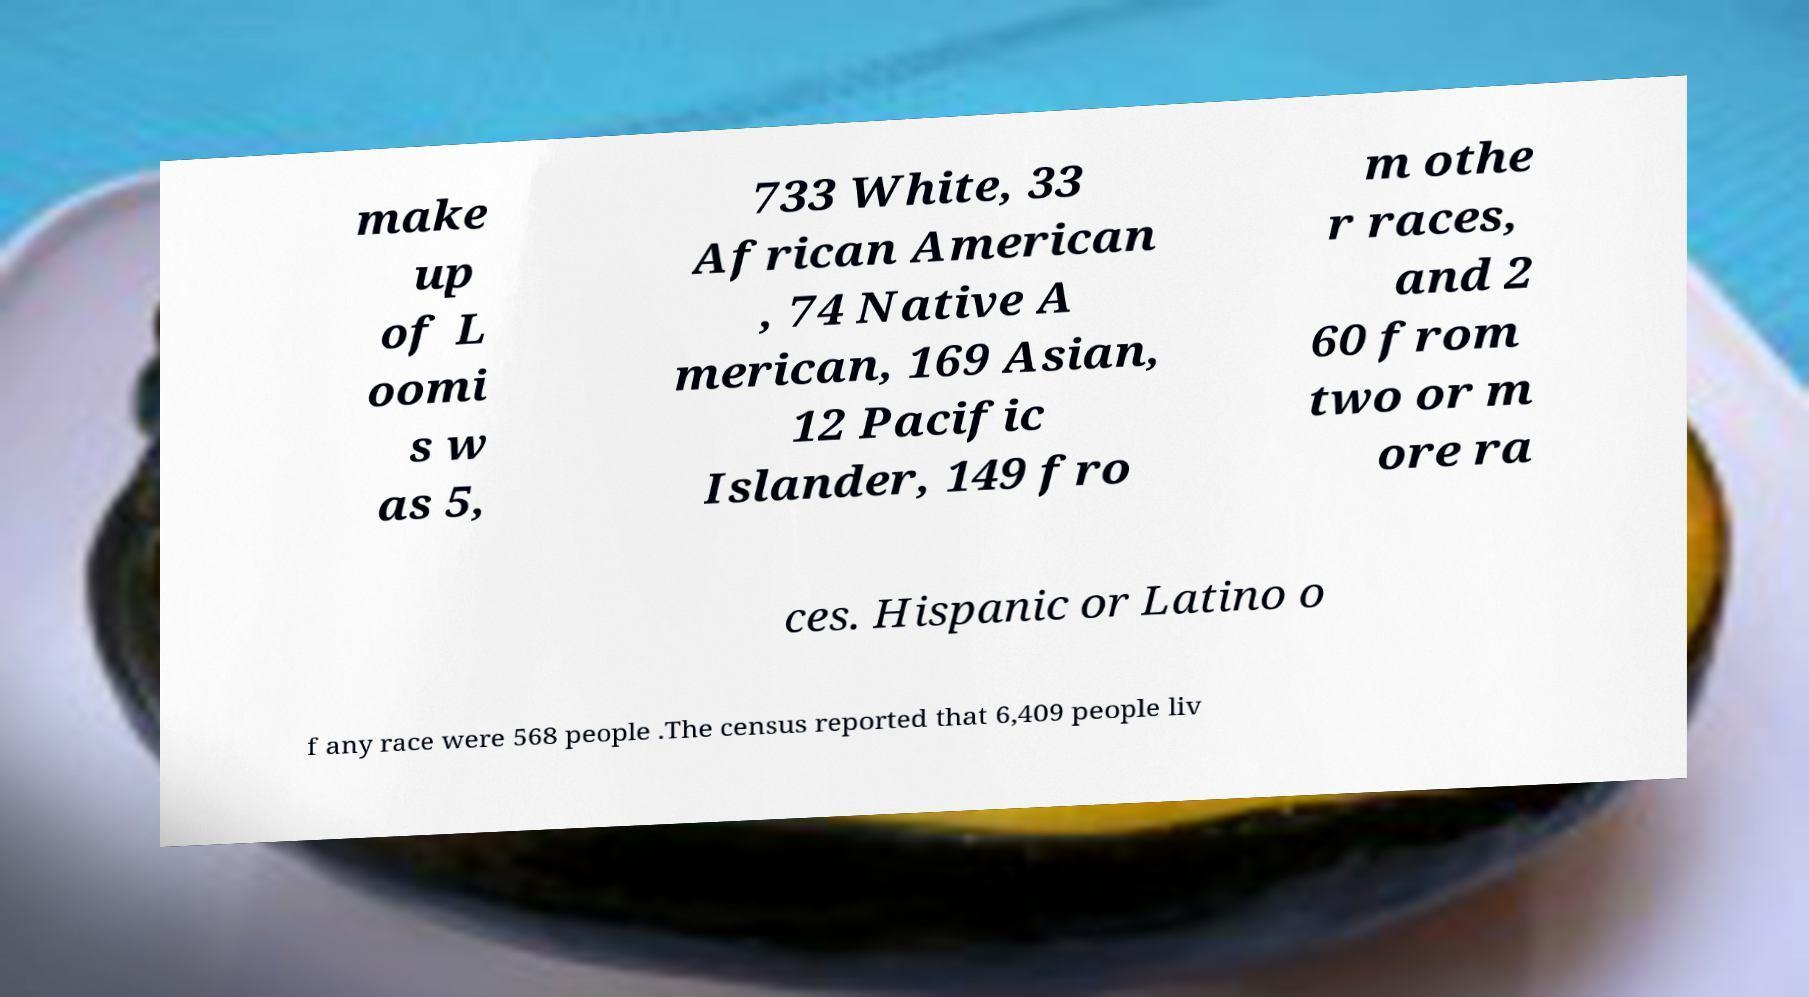I need the written content from this picture converted into text. Can you do that? make up of L oomi s w as 5, 733 White, 33 African American , 74 Native A merican, 169 Asian, 12 Pacific Islander, 149 fro m othe r races, and 2 60 from two or m ore ra ces. Hispanic or Latino o f any race were 568 people .The census reported that 6,409 people liv 